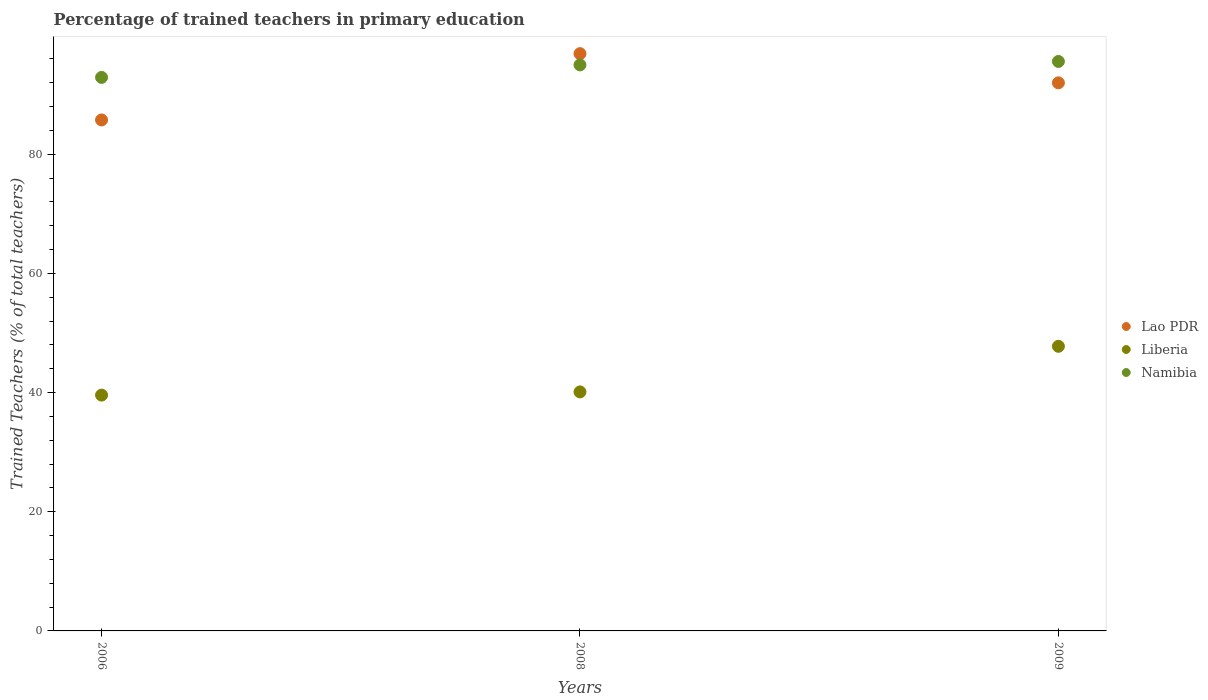How many different coloured dotlines are there?
Make the answer very short. 3. What is the percentage of trained teachers in Lao PDR in 2009?
Provide a succinct answer. 91.99. Across all years, what is the maximum percentage of trained teachers in Lao PDR?
Give a very brief answer. 96.89. Across all years, what is the minimum percentage of trained teachers in Lao PDR?
Your answer should be compact. 85.76. What is the total percentage of trained teachers in Liberia in the graph?
Keep it short and to the point. 127.46. What is the difference between the percentage of trained teachers in Liberia in 2006 and that in 2008?
Offer a terse response. -0.54. What is the difference between the percentage of trained teachers in Namibia in 2006 and the percentage of trained teachers in Liberia in 2009?
Offer a very short reply. 45.13. What is the average percentage of trained teachers in Lao PDR per year?
Give a very brief answer. 91.54. In the year 2006, what is the difference between the percentage of trained teachers in Lao PDR and percentage of trained teachers in Liberia?
Provide a short and direct response. 46.18. What is the ratio of the percentage of trained teachers in Liberia in 2008 to that in 2009?
Offer a terse response. 0.84. What is the difference between the highest and the second highest percentage of trained teachers in Lao PDR?
Your answer should be very brief. 4.9. What is the difference between the highest and the lowest percentage of trained teachers in Liberia?
Offer a very short reply. 8.19. In how many years, is the percentage of trained teachers in Namibia greater than the average percentage of trained teachers in Namibia taken over all years?
Your response must be concise. 2. Is the sum of the percentage of trained teachers in Liberia in 2006 and 2009 greater than the maximum percentage of trained teachers in Namibia across all years?
Your answer should be very brief. No. Is it the case that in every year, the sum of the percentage of trained teachers in Lao PDR and percentage of trained teachers in Namibia  is greater than the percentage of trained teachers in Liberia?
Your answer should be compact. Yes. Is the percentage of trained teachers in Namibia strictly greater than the percentage of trained teachers in Lao PDR over the years?
Ensure brevity in your answer.  No. What is the difference between two consecutive major ticks on the Y-axis?
Your answer should be compact. 20. Does the graph contain grids?
Your answer should be very brief. No. Where does the legend appear in the graph?
Provide a short and direct response. Center right. How many legend labels are there?
Offer a terse response. 3. How are the legend labels stacked?
Offer a very short reply. Vertical. What is the title of the graph?
Offer a terse response. Percentage of trained teachers in primary education. Does "Malawi" appear as one of the legend labels in the graph?
Your answer should be very brief. No. What is the label or title of the X-axis?
Your answer should be very brief. Years. What is the label or title of the Y-axis?
Your answer should be very brief. Trained Teachers (% of total teachers). What is the Trained Teachers (% of total teachers) in Lao PDR in 2006?
Provide a succinct answer. 85.76. What is the Trained Teachers (% of total teachers) of Liberia in 2006?
Make the answer very short. 39.58. What is the Trained Teachers (% of total teachers) of Namibia in 2006?
Provide a succinct answer. 92.9. What is the Trained Teachers (% of total teachers) in Lao PDR in 2008?
Provide a succinct answer. 96.89. What is the Trained Teachers (% of total teachers) of Liberia in 2008?
Ensure brevity in your answer.  40.11. What is the Trained Teachers (% of total teachers) of Namibia in 2008?
Keep it short and to the point. 95. What is the Trained Teachers (% of total teachers) of Lao PDR in 2009?
Give a very brief answer. 91.99. What is the Trained Teachers (% of total teachers) of Liberia in 2009?
Offer a very short reply. 47.77. What is the Trained Teachers (% of total teachers) in Namibia in 2009?
Your answer should be compact. 95.58. Across all years, what is the maximum Trained Teachers (% of total teachers) in Lao PDR?
Give a very brief answer. 96.89. Across all years, what is the maximum Trained Teachers (% of total teachers) of Liberia?
Offer a terse response. 47.77. Across all years, what is the maximum Trained Teachers (% of total teachers) of Namibia?
Offer a terse response. 95.58. Across all years, what is the minimum Trained Teachers (% of total teachers) of Lao PDR?
Your answer should be compact. 85.76. Across all years, what is the minimum Trained Teachers (% of total teachers) of Liberia?
Your answer should be very brief. 39.58. Across all years, what is the minimum Trained Teachers (% of total teachers) in Namibia?
Keep it short and to the point. 92.9. What is the total Trained Teachers (% of total teachers) of Lao PDR in the graph?
Give a very brief answer. 274.63. What is the total Trained Teachers (% of total teachers) of Liberia in the graph?
Your response must be concise. 127.46. What is the total Trained Teachers (% of total teachers) of Namibia in the graph?
Make the answer very short. 283.47. What is the difference between the Trained Teachers (% of total teachers) in Lao PDR in 2006 and that in 2008?
Keep it short and to the point. -11.13. What is the difference between the Trained Teachers (% of total teachers) in Liberia in 2006 and that in 2008?
Keep it short and to the point. -0.54. What is the difference between the Trained Teachers (% of total teachers) in Namibia in 2006 and that in 2008?
Give a very brief answer. -2.1. What is the difference between the Trained Teachers (% of total teachers) in Lao PDR in 2006 and that in 2009?
Your answer should be very brief. -6.23. What is the difference between the Trained Teachers (% of total teachers) in Liberia in 2006 and that in 2009?
Provide a succinct answer. -8.19. What is the difference between the Trained Teachers (% of total teachers) of Namibia in 2006 and that in 2009?
Provide a short and direct response. -2.68. What is the difference between the Trained Teachers (% of total teachers) in Lao PDR in 2008 and that in 2009?
Ensure brevity in your answer.  4.9. What is the difference between the Trained Teachers (% of total teachers) in Liberia in 2008 and that in 2009?
Offer a terse response. -7.65. What is the difference between the Trained Teachers (% of total teachers) in Namibia in 2008 and that in 2009?
Make the answer very short. -0.58. What is the difference between the Trained Teachers (% of total teachers) in Lao PDR in 2006 and the Trained Teachers (% of total teachers) in Liberia in 2008?
Your answer should be compact. 45.65. What is the difference between the Trained Teachers (% of total teachers) of Lao PDR in 2006 and the Trained Teachers (% of total teachers) of Namibia in 2008?
Your response must be concise. -9.24. What is the difference between the Trained Teachers (% of total teachers) of Liberia in 2006 and the Trained Teachers (% of total teachers) of Namibia in 2008?
Keep it short and to the point. -55.42. What is the difference between the Trained Teachers (% of total teachers) of Lao PDR in 2006 and the Trained Teachers (% of total teachers) of Liberia in 2009?
Make the answer very short. 37.99. What is the difference between the Trained Teachers (% of total teachers) in Lao PDR in 2006 and the Trained Teachers (% of total teachers) in Namibia in 2009?
Your answer should be very brief. -9.82. What is the difference between the Trained Teachers (% of total teachers) in Liberia in 2006 and the Trained Teachers (% of total teachers) in Namibia in 2009?
Offer a very short reply. -56. What is the difference between the Trained Teachers (% of total teachers) in Lao PDR in 2008 and the Trained Teachers (% of total teachers) in Liberia in 2009?
Give a very brief answer. 49.12. What is the difference between the Trained Teachers (% of total teachers) of Lao PDR in 2008 and the Trained Teachers (% of total teachers) of Namibia in 2009?
Offer a very short reply. 1.31. What is the difference between the Trained Teachers (% of total teachers) in Liberia in 2008 and the Trained Teachers (% of total teachers) in Namibia in 2009?
Keep it short and to the point. -55.46. What is the average Trained Teachers (% of total teachers) of Lao PDR per year?
Your answer should be compact. 91.54. What is the average Trained Teachers (% of total teachers) of Liberia per year?
Ensure brevity in your answer.  42.49. What is the average Trained Teachers (% of total teachers) in Namibia per year?
Make the answer very short. 94.49. In the year 2006, what is the difference between the Trained Teachers (% of total teachers) of Lao PDR and Trained Teachers (% of total teachers) of Liberia?
Provide a short and direct response. 46.18. In the year 2006, what is the difference between the Trained Teachers (% of total teachers) of Lao PDR and Trained Teachers (% of total teachers) of Namibia?
Make the answer very short. -7.14. In the year 2006, what is the difference between the Trained Teachers (% of total teachers) of Liberia and Trained Teachers (% of total teachers) of Namibia?
Ensure brevity in your answer.  -53.32. In the year 2008, what is the difference between the Trained Teachers (% of total teachers) of Lao PDR and Trained Teachers (% of total teachers) of Liberia?
Give a very brief answer. 56.77. In the year 2008, what is the difference between the Trained Teachers (% of total teachers) in Lao PDR and Trained Teachers (% of total teachers) in Namibia?
Offer a very short reply. 1.89. In the year 2008, what is the difference between the Trained Teachers (% of total teachers) in Liberia and Trained Teachers (% of total teachers) in Namibia?
Make the answer very short. -54.88. In the year 2009, what is the difference between the Trained Teachers (% of total teachers) in Lao PDR and Trained Teachers (% of total teachers) in Liberia?
Give a very brief answer. 44.22. In the year 2009, what is the difference between the Trained Teachers (% of total teachers) of Lao PDR and Trained Teachers (% of total teachers) of Namibia?
Your answer should be very brief. -3.59. In the year 2009, what is the difference between the Trained Teachers (% of total teachers) in Liberia and Trained Teachers (% of total teachers) in Namibia?
Your answer should be compact. -47.81. What is the ratio of the Trained Teachers (% of total teachers) in Lao PDR in 2006 to that in 2008?
Your answer should be very brief. 0.89. What is the ratio of the Trained Teachers (% of total teachers) of Liberia in 2006 to that in 2008?
Make the answer very short. 0.99. What is the ratio of the Trained Teachers (% of total teachers) of Namibia in 2006 to that in 2008?
Your answer should be very brief. 0.98. What is the ratio of the Trained Teachers (% of total teachers) in Lao PDR in 2006 to that in 2009?
Your answer should be very brief. 0.93. What is the ratio of the Trained Teachers (% of total teachers) of Liberia in 2006 to that in 2009?
Make the answer very short. 0.83. What is the ratio of the Trained Teachers (% of total teachers) in Lao PDR in 2008 to that in 2009?
Offer a very short reply. 1.05. What is the ratio of the Trained Teachers (% of total teachers) of Liberia in 2008 to that in 2009?
Make the answer very short. 0.84. What is the difference between the highest and the second highest Trained Teachers (% of total teachers) in Lao PDR?
Your answer should be very brief. 4.9. What is the difference between the highest and the second highest Trained Teachers (% of total teachers) in Liberia?
Provide a short and direct response. 7.65. What is the difference between the highest and the second highest Trained Teachers (% of total teachers) in Namibia?
Your response must be concise. 0.58. What is the difference between the highest and the lowest Trained Teachers (% of total teachers) of Lao PDR?
Provide a succinct answer. 11.13. What is the difference between the highest and the lowest Trained Teachers (% of total teachers) in Liberia?
Give a very brief answer. 8.19. What is the difference between the highest and the lowest Trained Teachers (% of total teachers) of Namibia?
Provide a succinct answer. 2.68. 